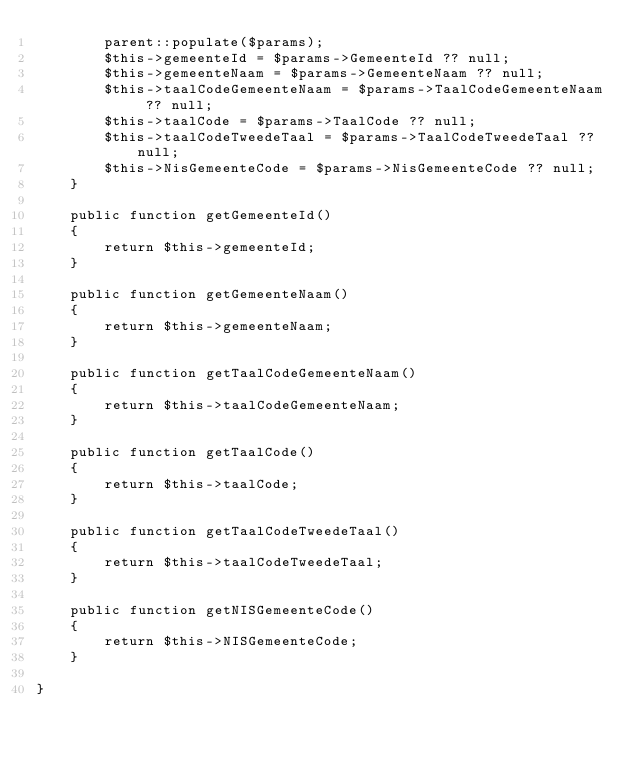<code> <loc_0><loc_0><loc_500><loc_500><_PHP_>        parent::populate($params);
        $this->gemeenteId = $params->GemeenteId ?? null;
        $this->gemeenteNaam = $params->GemeenteNaam ?? null;
        $this->taalCodeGemeenteNaam = $params->TaalCodeGemeenteNaam ?? null;        
        $this->taalCode = $params->TaalCode ?? null;
        $this->taalCodeTweedeTaal = $params->TaalCodeTweedeTaal ?? null;
        $this->NisGemeenteCode = $params->NisGemeenteCode ?? null;  
    }

    public function getGemeenteId()
    {
        return $this->gemeenteId;
    }

    public function getGemeenteNaam()
    {
        return $this->gemeenteNaam;
    }

    public function getTaalCodeGemeenteNaam()
    {
        return $this->taalCodeGemeenteNaam;
    }

    public function getTaalCode()
    {
        return $this->taalCode;
    }

    public function getTaalCodeTweedeTaal()
    {
        return $this->taalCodeTweedeTaal;
    }

    public function getNISGemeenteCode()
    {
        return $this->NISGemeenteCode;
    }

}</code> 